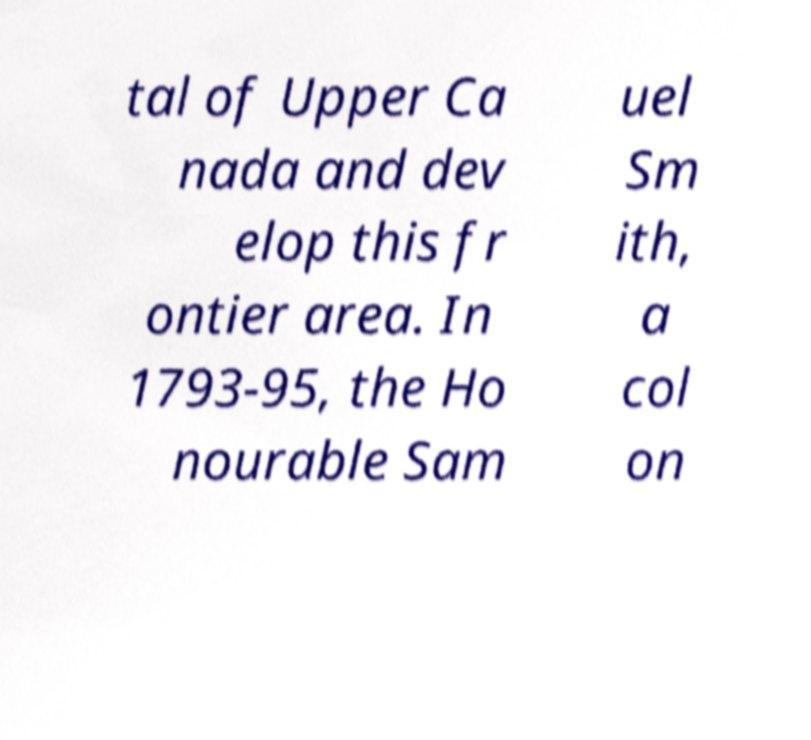Please identify and transcribe the text found in this image. tal of Upper Ca nada and dev elop this fr ontier area. In 1793-95, the Ho nourable Sam uel Sm ith, a col on 